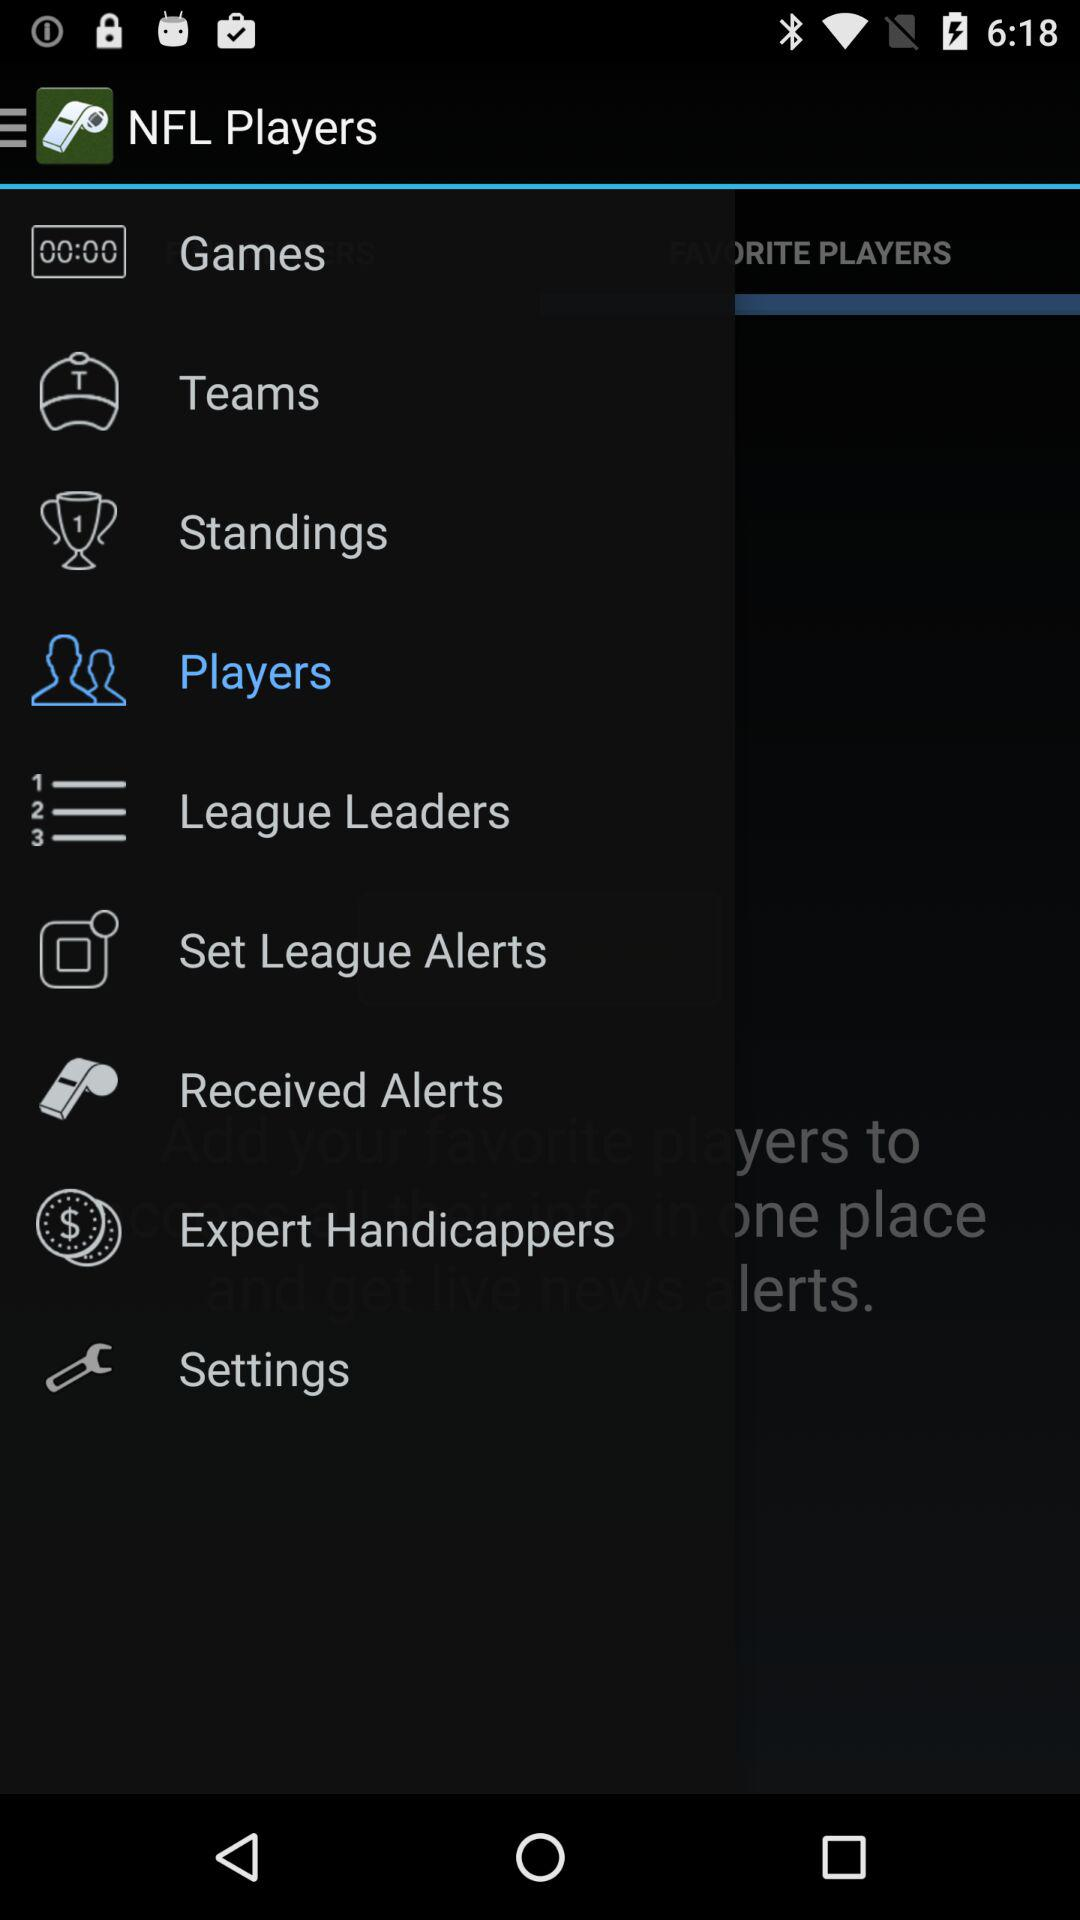Which item is selected? The selected item is "Players". 